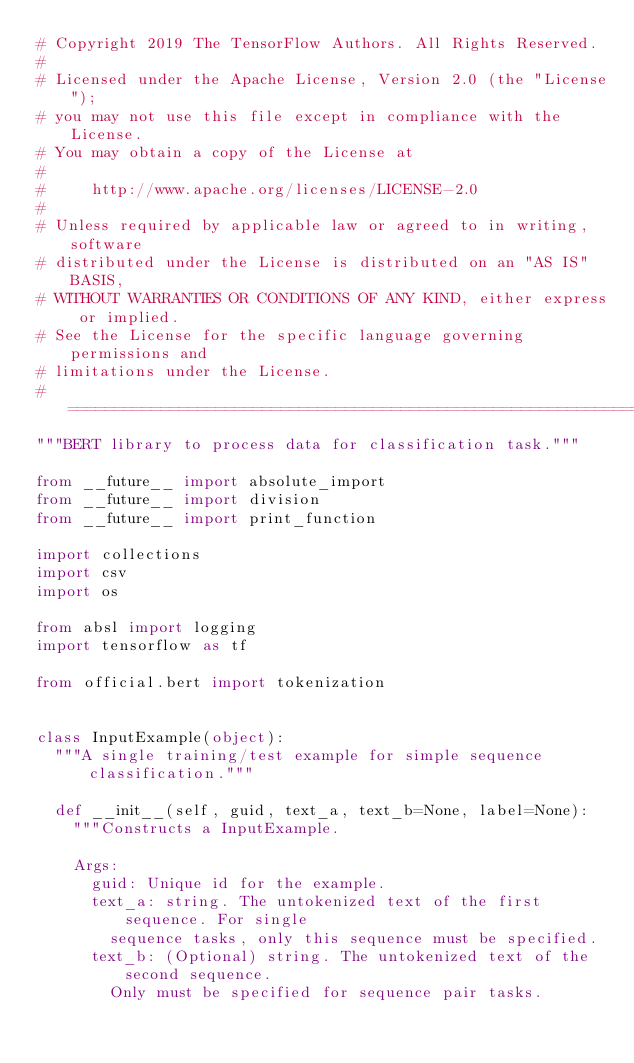<code> <loc_0><loc_0><loc_500><loc_500><_Python_># Copyright 2019 The TensorFlow Authors. All Rights Reserved.
#
# Licensed under the Apache License, Version 2.0 (the "License");
# you may not use this file except in compliance with the License.
# You may obtain a copy of the License at
#
#     http://www.apache.org/licenses/LICENSE-2.0
#
# Unless required by applicable law or agreed to in writing, software
# distributed under the License is distributed on an "AS IS" BASIS,
# WITHOUT WARRANTIES OR CONDITIONS OF ANY KIND, either express or implied.
# See the License for the specific language governing permissions and
# limitations under the License.
# ==============================================================================
"""BERT library to process data for classification task."""

from __future__ import absolute_import
from __future__ import division
from __future__ import print_function

import collections
import csv
import os

from absl import logging
import tensorflow as tf

from official.bert import tokenization


class InputExample(object):
  """A single training/test example for simple sequence classification."""

  def __init__(self, guid, text_a, text_b=None, label=None):
    """Constructs a InputExample.

    Args:
      guid: Unique id for the example.
      text_a: string. The untokenized text of the first sequence. For single
        sequence tasks, only this sequence must be specified.
      text_b: (Optional) string. The untokenized text of the second sequence.
        Only must be specified for sequence pair tasks.</code> 